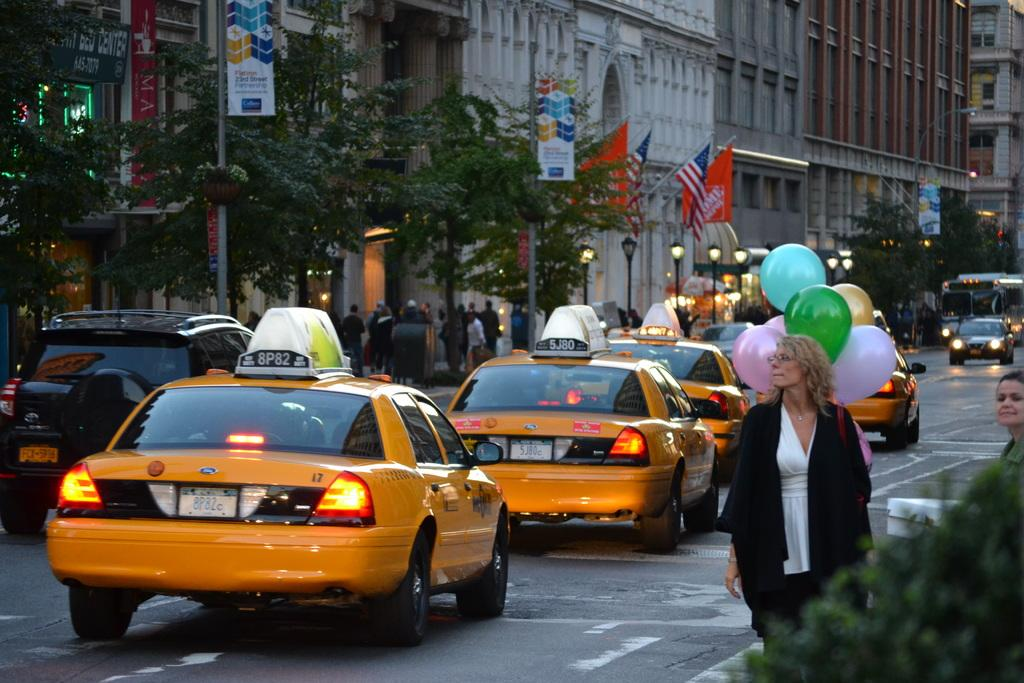<image>
Write a terse but informative summary of the picture. A taxi driving down the road with the numbers and letters 8P82 on it 